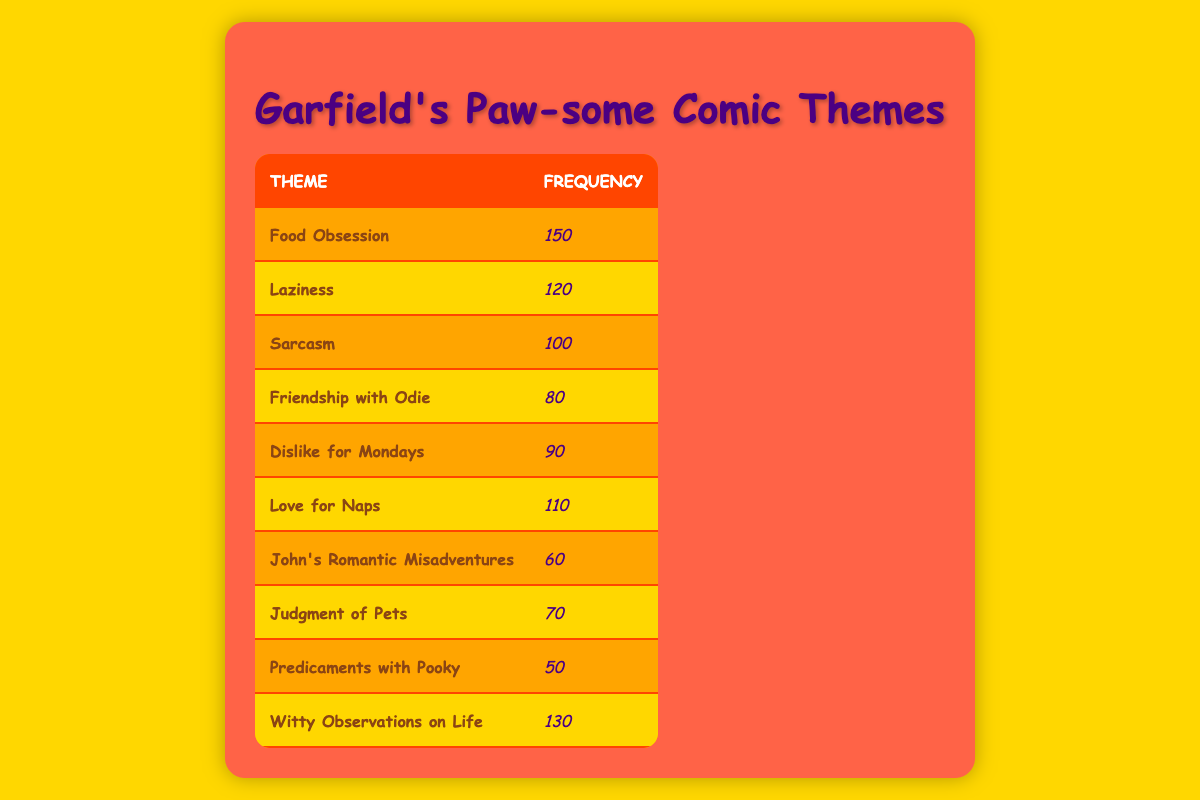What is the most frequent theme in the Garfield comic strips? "Food Obsession" appears most frequently with a count of 150, making it the highest in the table.
Answer: Food Obsession How many times is "Laziness" mentioned in the comics? "Laziness" has a frequency count of 120, which can be found directly in the table.
Answer: 120 Is there a theme related to weekends in the table? The table does not explicitly mention a theme related to weekends; thus the answer is no.
Answer: No What is the total frequency of themes related to Odie? The themes related to Odie are "Friendship with Odie" (80) and "Judgment of Pets" (70), which adds up to 80 + 70 = 150.
Answer: 150 What theme has the lowest frequency? "Predicaments with Pooky" has the lowest frequency of 50, as indicated in the table.
Answer: Predicaments with Pooky What is the average frequency of the themes in the table? To find the average, sum the frequencies (150 + 120 + 100 + 80 + 90 + 110 + 60 + 70 + 50 + 130 = 1,030) and divide by the number of themes (10), giving an average of 1,030 / 10 = 103.
Answer: 103 Is "Dislike for Mondays" mentioned more frequently than "John's Romantic Misadventures"? "Dislike for Mondays" has a frequency of 90 while "John's Romantic Misadventures" is at 60, so the former is mentioned more often.
Answer: Yes Which themes are mentioned more than 100 times? The themes that surpass 100 are "Food Obsession" (150), "Laziness" (120), "Witty Observations on Life" (130), and "Love for Naps" (110).
Answer: Food Obsession, Laziness, Witty Observations on Life, Love for Naps What is the difference in frequency between "Sarcasm" and "Judgment of Pets"? "Sarcasm" has a frequency of 100 and "Judgment of Pets" has 70, so the difference is 100 - 70 = 30.
Answer: 30 